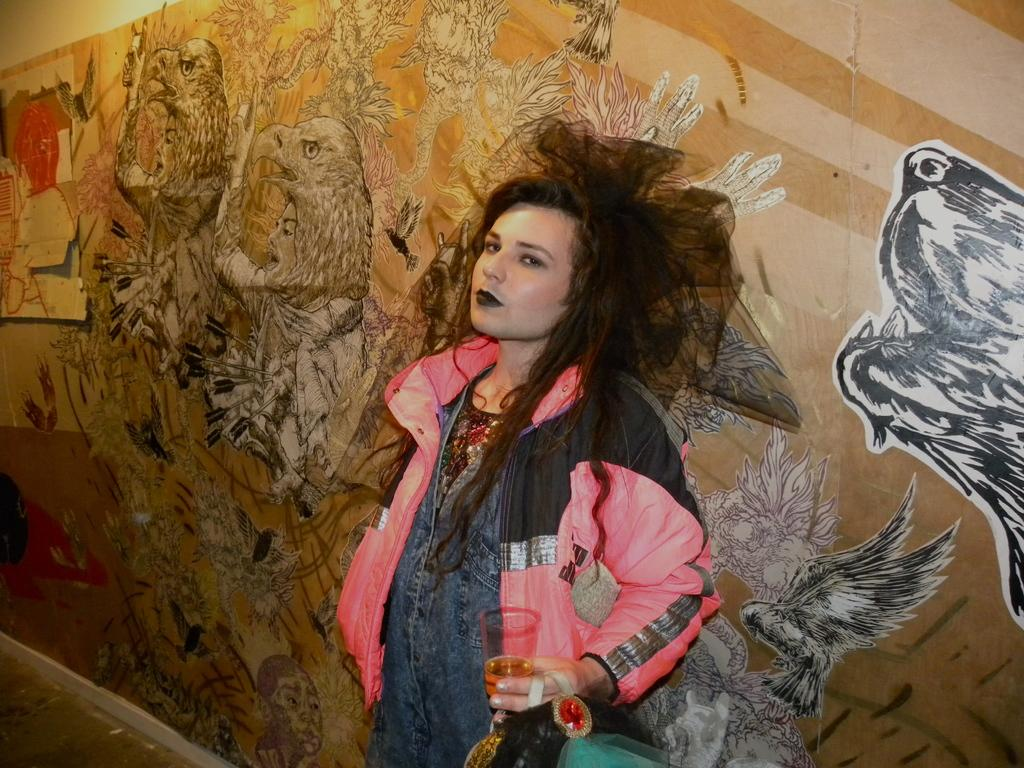Who is present in the image? There is a woman in the image. What is the woman wearing? The woman is wearing a jacket. What is the woman holding in her hands? The woman is holding a glass in her hands. Where is the woman standing in relation to the wall? The woman is standing near a wall. What can be seen on the wall? The wall is painted with pictures. What type of celery is being used as a decoration on the wall in the image? There is no celery present in the image; the wall is painted with pictures. Can you see a fan in the image? There is no fan visible in the image. 